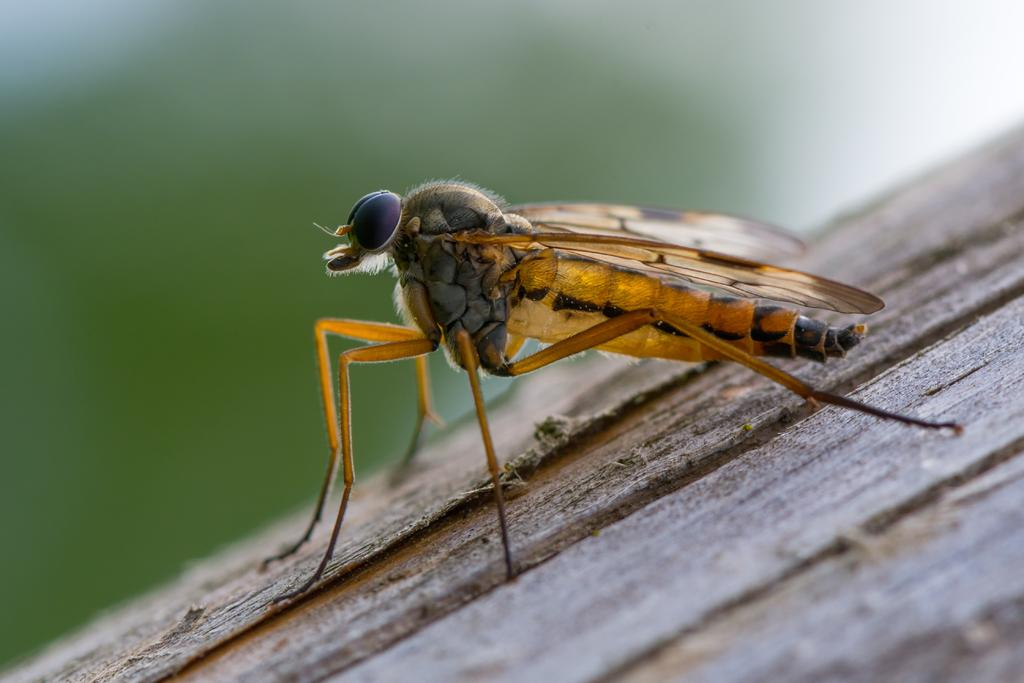What is the main subject of the image? There is an insect in the center of the image. What type of flame can be seen coming from the insect's stomach in the image? There is no flame or any indication of a flame in the image; it features an insect in the center. 